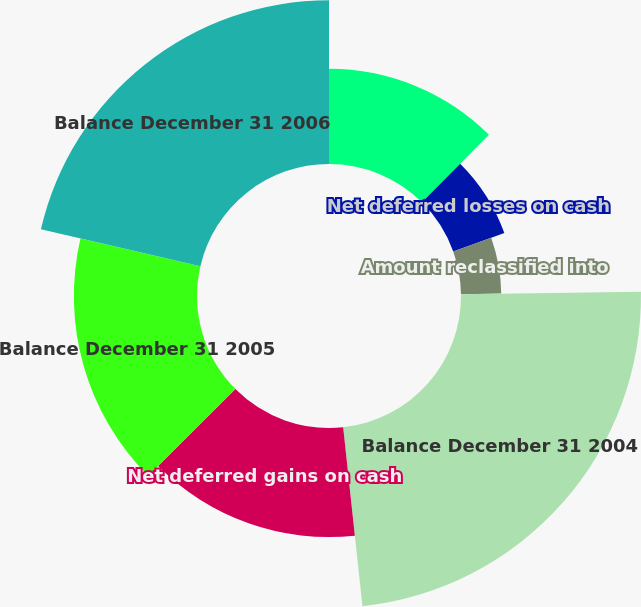<chart> <loc_0><loc_0><loc_500><loc_500><pie_chart><fcel>Balance December 31 2003<fcel>Net deferred losses on cash<fcel>Amount reclassified into<fcel>Balance December 31 2004<fcel>Net deferred gains on cash<fcel>Balance December 31 2005<fcel>Balance December 31 2006<nl><fcel>12.43%<fcel>7.09%<fcel>5.26%<fcel>23.51%<fcel>14.25%<fcel>16.08%<fcel>21.38%<nl></chart> 